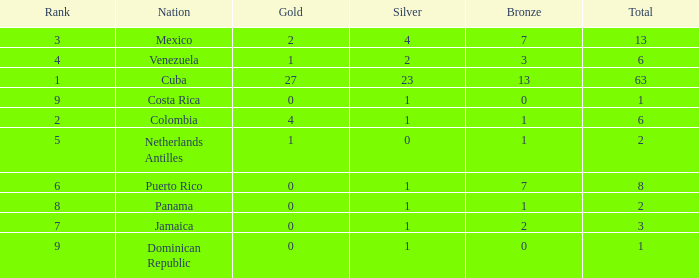What nation has the lowest gold average that has a rank over 9? None. 